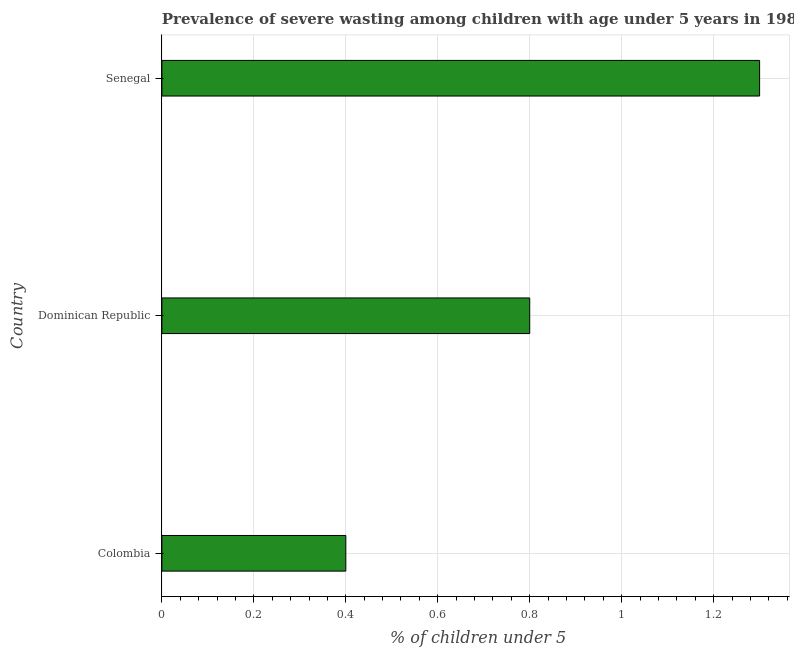Does the graph contain any zero values?
Offer a very short reply. No. Does the graph contain grids?
Keep it short and to the point. Yes. What is the title of the graph?
Ensure brevity in your answer.  Prevalence of severe wasting among children with age under 5 years in 1986. What is the label or title of the X-axis?
Keep it short and to the point.  % of children under 5. What is the prevalence of severe wasting in Senegal?
Offer a terse response. 1.3. Across all countries, what is the maximum prevalence of severe wasting?
Your answer should be very brief. 1.3. Across all countries, what is the minimum prevalence of severe wasting?
Your answer should be very brief. 0.4. In which country was the prevalence of severe wasting maximum?
Offer a terse response. Senegal. What is the sum of the prevalence of severe wasting?
Provide a succinct answer. 2.5. What is the average prevalence of severe wasting per country?
Give a very brief answer. 0.83. What is the median prevalence of severe wasting?
Make the answer very short. 0.8. In how many countries, is the prevalence of severe wasting greater than 0.92 %?
Ensure brevity in your answer.  1. What is the ratio of the prevalence of severe wasting in Dominican Republic to that in Senegal?
Your response must be concise. 0.61. What is the difference between the highest and the second highest prevalence of severe wasting?
Ensure brevity in your answer.  0.5. What is the difference between the highest and the lowest prevalence of severe wasting?
Offer a terse response. 0.9. In how many countries, is the prevalence of severe wasting greater than the average prevalence of severe wasting taken over all countries?
Provide a succinct answer. 1. How many bars are there?
Offer a terse response. 3. Are all the bars in the graph horizontal?
Keep it short and to the point. Yes. What is the difference between two consecutive major ticks on the X-axis?
Ensure brevity in your answer.  0.2. Are the values on the major ticks of X-axis written in scientific E-notation?
Provide a short and direct response. No. What is the  % of children under 5 in Colombia?
Keep it short and to the point. 0.4. What is the  % of children under 5 of Dominican Republic?
Keep it short and to the point. 0.8. What is the  % of children under 5 in Senegal?
Give a very brief answer. 1.3. What is the difference between the  % of children under 5 in Colombia and Dominican Republic?
Offer a terse response. -0.4. What is the difference between the  % of children under 5 in Colombia and Senegal?
Offer a very short reply. -0.9. What is the ratio of the  % of children under 5 in Colombia to that in Dominican Republic?
Your answer should be very brief. 0.5. What is the ratio of the  % of children under 5 in Colombia to that in Senegal?
Offer a terse response. 0.31. What is the ratio of the  % of children under 5 in Dominican Republic to that in Senegal?
Offer a terse response. 0.61. 